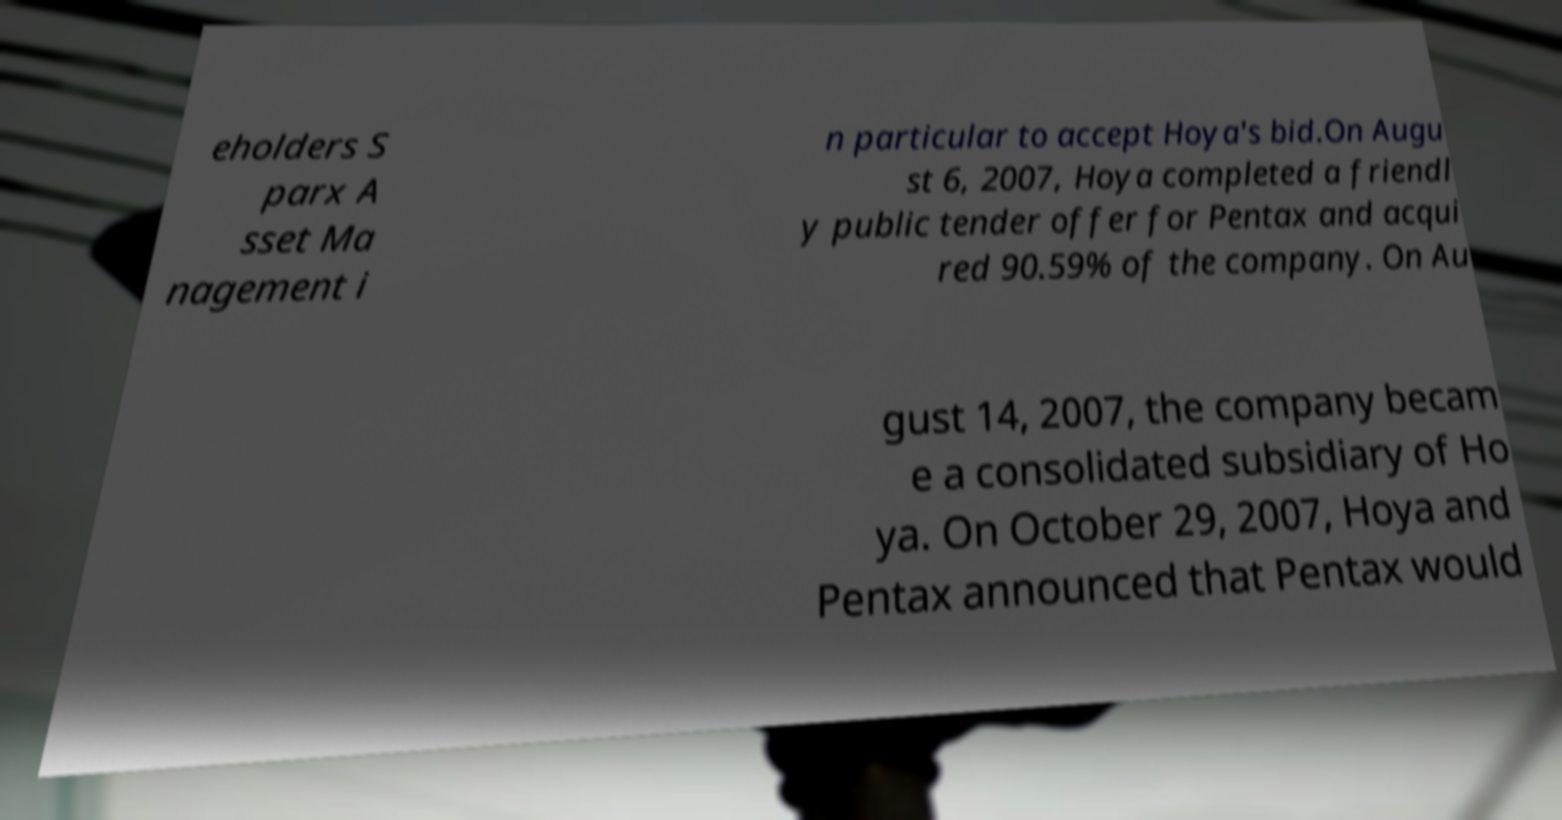Can you accurately transcribe the text from the provided image for me? eholders S parx A sset Ma nagement i n particular to accept Hoya's bid.On Augu st 6, 2007, Hoya completed a friendl y public tender offer for Pentax and acqui red 90.59% of the company. On Au gust 14, 2007, the company becam e a consolidated subsidiary of Ho ya. On October 29, 2007, Hoya and Pentax announced that Pentax would 